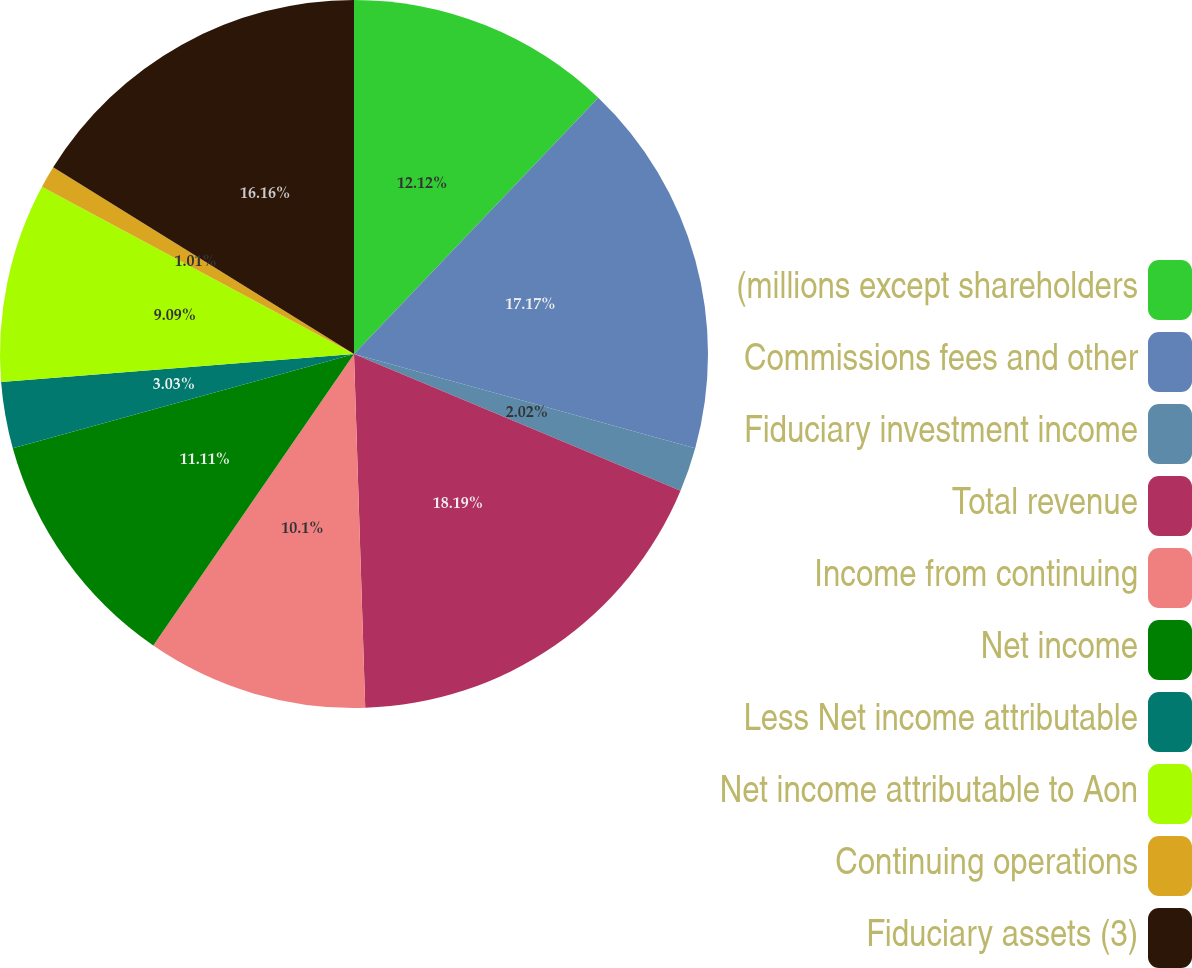Convert chart. <chart><loc_0><loc_0><loc_500><loc_500><pie_chart><fcel>(millions except shareholders<fcel>Commissions fees and other<fcel>Fiduciary investment income<fcel>Total revenue<fcel>Income from continuing<fcel>Net income<fcel>Less Net income attributable<fcel>Net income attributable to Aon<fcel>Continuing operations<fcel>Fiduciary assets (3)<nl><fcel>12.12%<fcel>17.17%<fcel>2.02%<fcel>18.18%<fcel>10.1%<fcel>11.11%<fcel>3.03%<fcel>9.09%<fcel>1.01%<fcel>16.16%<nl></chart> 